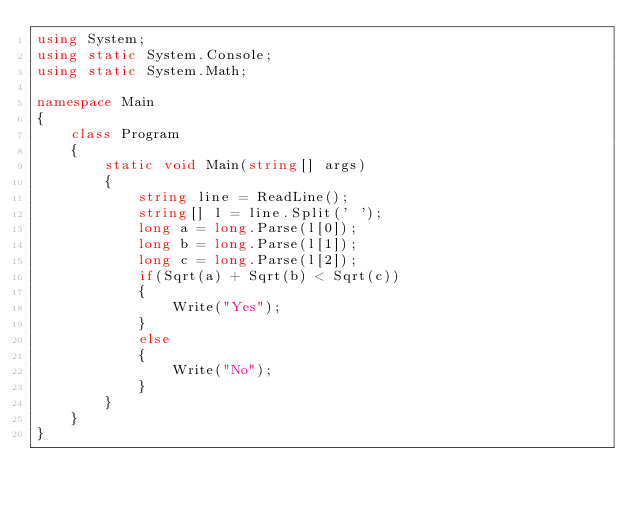Convert code to text. <code><loc_0><loc_0><loc_500><loc_500><_C#_>using System;
using static System.Console;
using static System.Math;

namespace Main
{
    class Program
    {
        static void Main(string[] args)
        {
            string line = ReadLine();
            string[] l = line.Split(' ');
            long a = long.Parse(l[0]);
            long b = long.Parse(l[1]);
            long c = long.Parse(l[2]);
            if(Sqrt(a) + Sqrt(b) < Sqrt(c))
            {
                Write("Yes");
            }
            else
            {
                Write("No");
            }
        }
    }
}</code> 